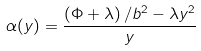<formula> <loc_0><loc_0><loc_500><loc_500>\alpha ( y ) = \frac { \left ( \Phi + \lambda \right ) / b ^ { 2 } - \lambda y ^ { 2 } } { y }</formula> 